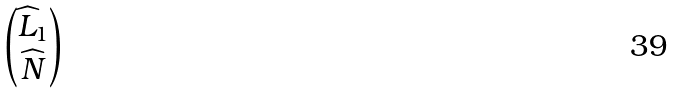<formula> <loc_0><loc_0><loc_500><loc_500>\begin{pmatrix} \widehat { L } _ { 1 } \\ \widehat { N } \end{pmatrix}</formula> 